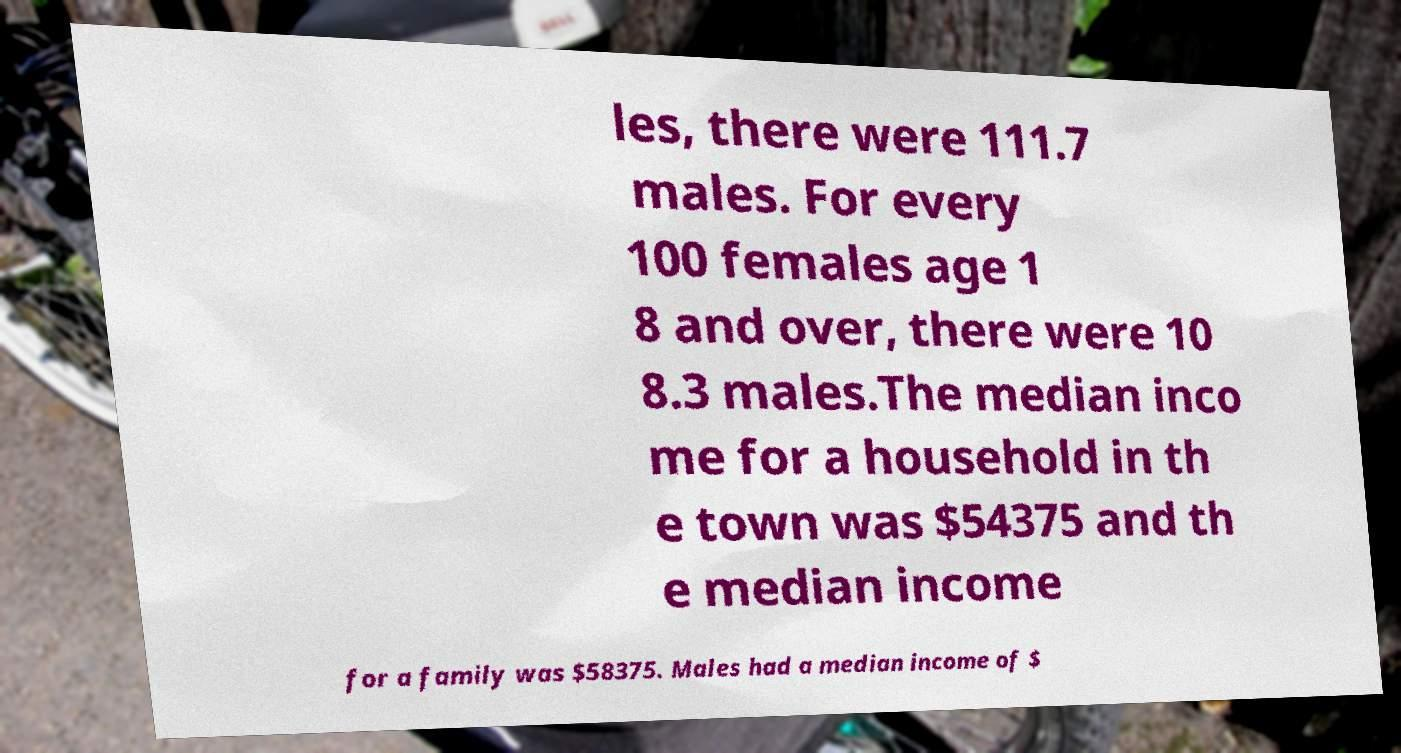Could you assist in decoding the text presented in this image and type it out clearly? les, there were 111.7 males. For every 100 females age 1 8 and over, there were 10 8.3 males.The median inco me for a household in th e town was $54375 and th e median income for a family was $58375. Males had a median income of $ 